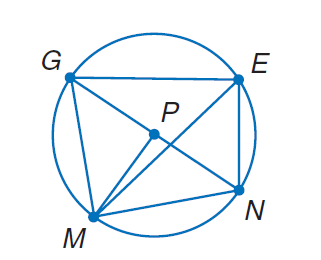Answer the mathemtical geometry problem and directly provide the correct option letter.
Question: In \odot P, m \widehat E N = 66 and m \angle G P M = 89. Find m \angle G N M.
Choices: A: 44.5 B: 66 C: 89 D: 155 A 